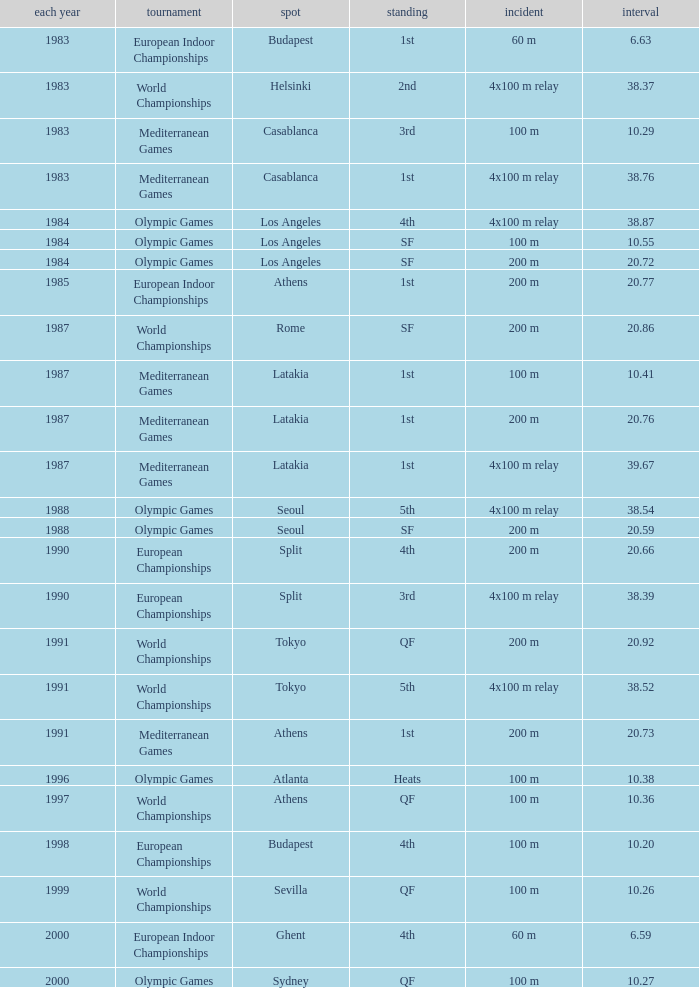What Venue has a Year smaller than 1991, Time larger than 10.29, Competition of mediterranean games, and Event of 4x100 m relay? Casablanca, Latakia. 